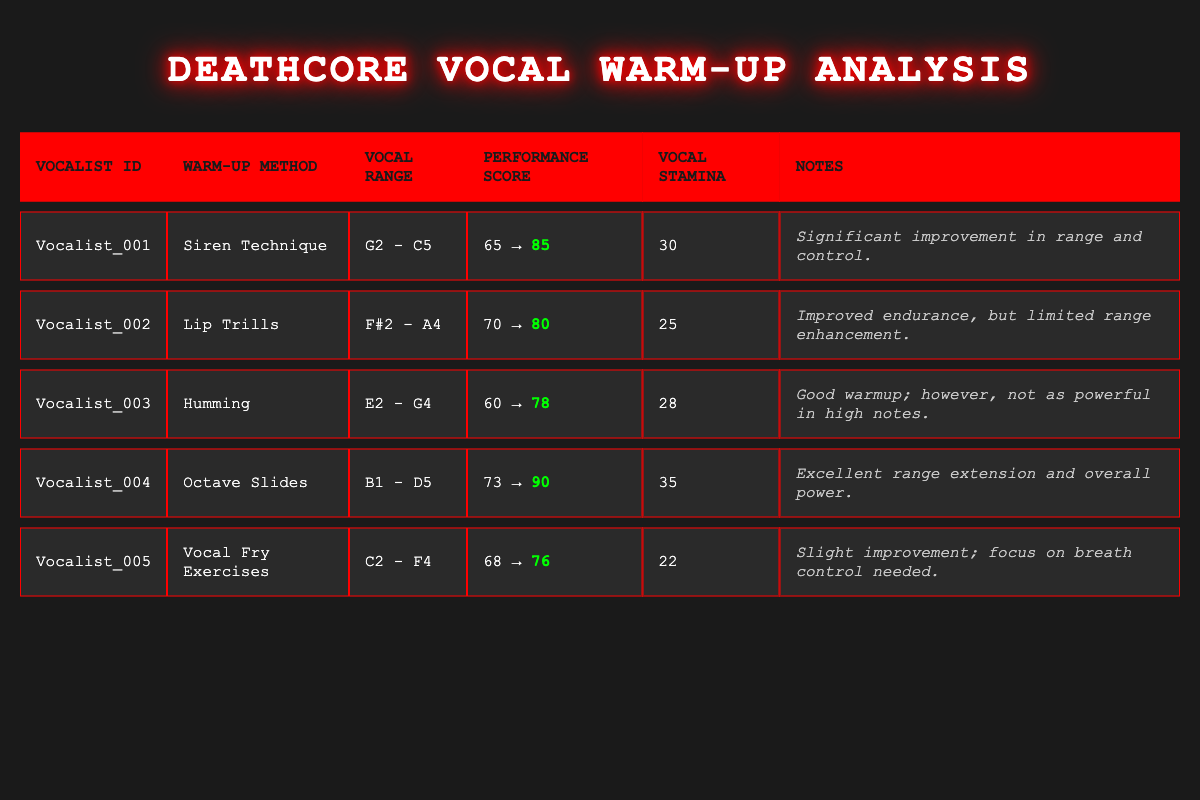What warm-up method yielded the highest performance score improvement? To find the highest performance score improvement, compare the pre and post scores for each warm-up method. By calculating the differences: Siren Technique (20), Lip Trills (10), Humming (18), Octave Slides (17), Vocal Fry Exercises (8). The Siren Technique has the largest difference of 20.
Answer: Siren Technique Did Vocalist_002 show a higher pre or post performance score? The pre-performance score of Vocalist_002 is 70, and the post-performance score is 80. Since 80 is greater than 70, the post score is higher.
Answer: Yes Which vocalist had the highest start range? The start ranges are G2 (Vocalist_001), F#2 (Vocalist_002), E2 (Vocalist_003), B1 (Vocalist_004), and C2 (Vocalist_005). The highest start range is G2 from Vocalist_001.
Answer: Vocalist_001 What is the average vocal stamina among all vocalists? To calculate the average vocal stamina, sum the vocal stamina values (30 + 25 + 28 + 35 + 22 = 140) and divide by the number of vocalists, which is 5. Thus, the average is 140/5 = 28.
Answer: 28 Was there any warm-up method where the performance score decreased? Reviewing the performance scores for each method, the post score is 85 (Vocalist_001), 80 (Vocalist_002), 78 (Vocalist_003), 90 (Vocalist_004), and 76 (Vocalist_005). All the scores increased from pre to post in every case.
Answer: No 